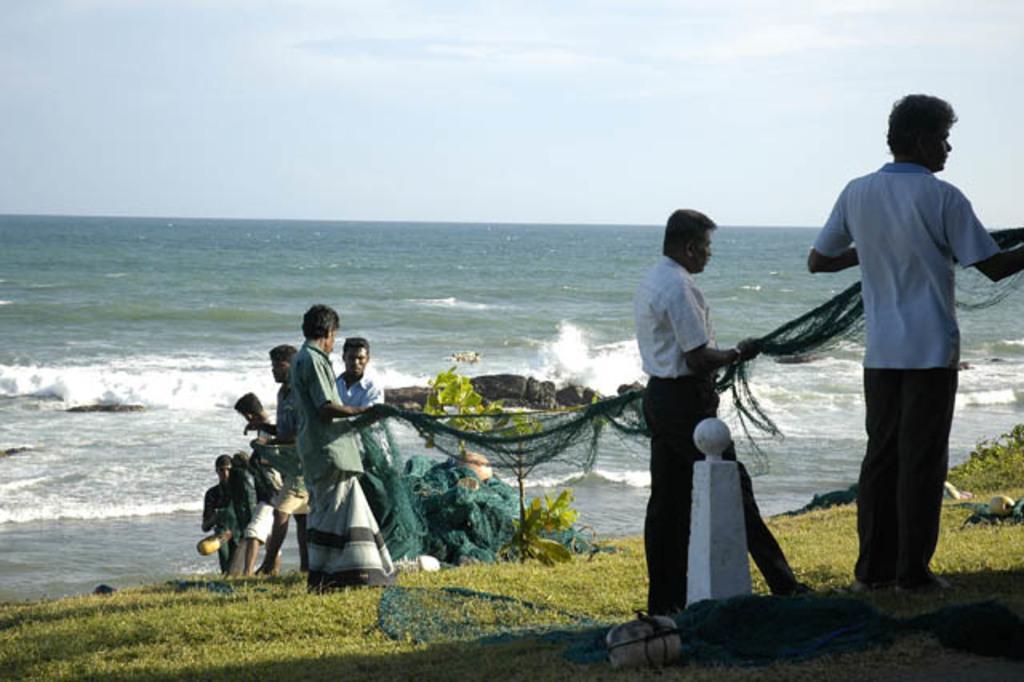Could you give a brief overview of what you see in this image? In this picture I can see there are a few people standing, holding a net and there is grass on the floor and there are few bags, plant, rock and there is an ocean in the backdrop and the sky is clear. 